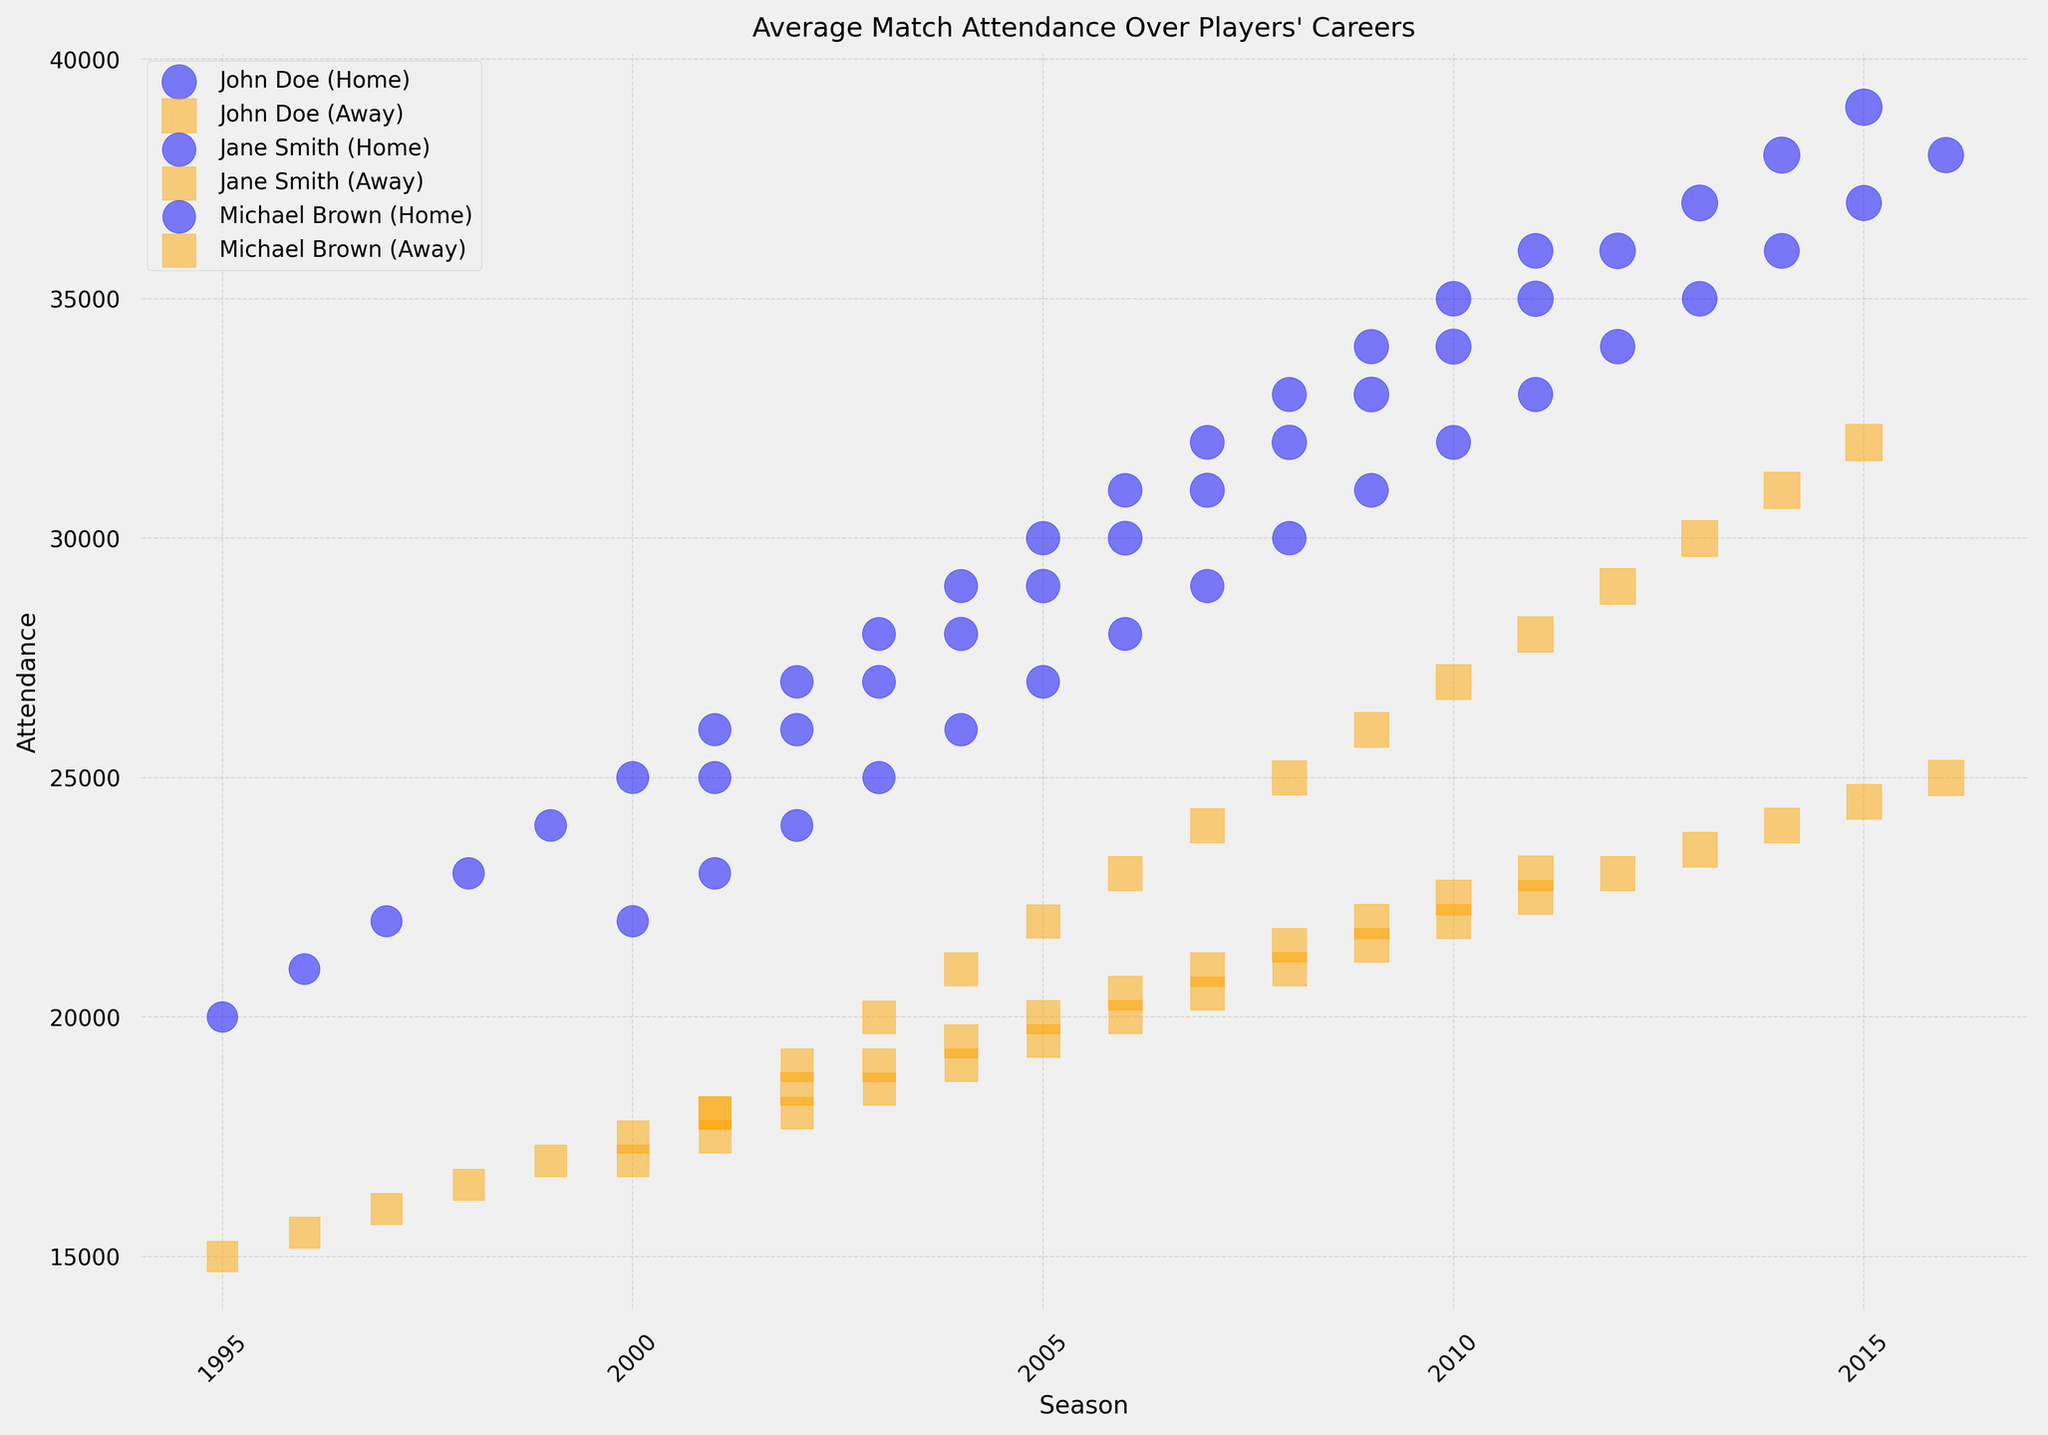How does the average home game attendance change for John Doe over his career? Look for the home game attendance values for John Doe for each season from 2001 to 2015. Observe whether the values increase, decrease, or remain the same. The values are increasing steadily each year.
Answer: Increases steadily Which player had the highest away game attendance in any season? Compare the away game attendance values for all players across all seasons. Determine the highest value, which is 32000 for John Doe in 2015.
Answer: John Doe During which season did Jane Smith have a greater difference between home and away game attendances? For each season, calculate the difference between home and away game attendances for Jane Smith by subtracting away attendance from home attendance. The greatest difference is in 2016 with 38000 (home) - 25000 (away) = 13000.
Answer: 2016 Which player had more consistent home game attendance throughout their career? Compare the change in home game attendance values over the years for each player. Evaluate variation (fluctuation) and steady patterns. Michael Brown's values are consistently increasing, but with small increments more steadily distributed over the years compared to others.
Answer: Michael Brown For the year 2007, how does the home game attendance of John Doe compare to Michael Brown? Locate the home game attendance values for both John Doe (31000) and Michael Brown (32000) in 2007 and compare them.
Answer: Michael Brown's attendance is higher Which player showed the highest total growth in home game attendance over their career? Subtract the earliest home game attendance from the latest home game attendance for each player. The differences are: John Doe: (2015-2001), 39000-25000=14000; Jane Smith: (2016-2000), 38000-22000=16000; Michael Brown: (2011-1995), 36000-20000=16000. Both Jane Smith and Michael Brown show a growth of 16000.
Answer: Jane Smith and Michael Brown Did any player's away game attendance exceed their home game attendance in any season? Compare home and away game attendance values for each player across all seasons. No player's away game attendance exceeds their home game attendance in any of the seasons.
Answer: No 